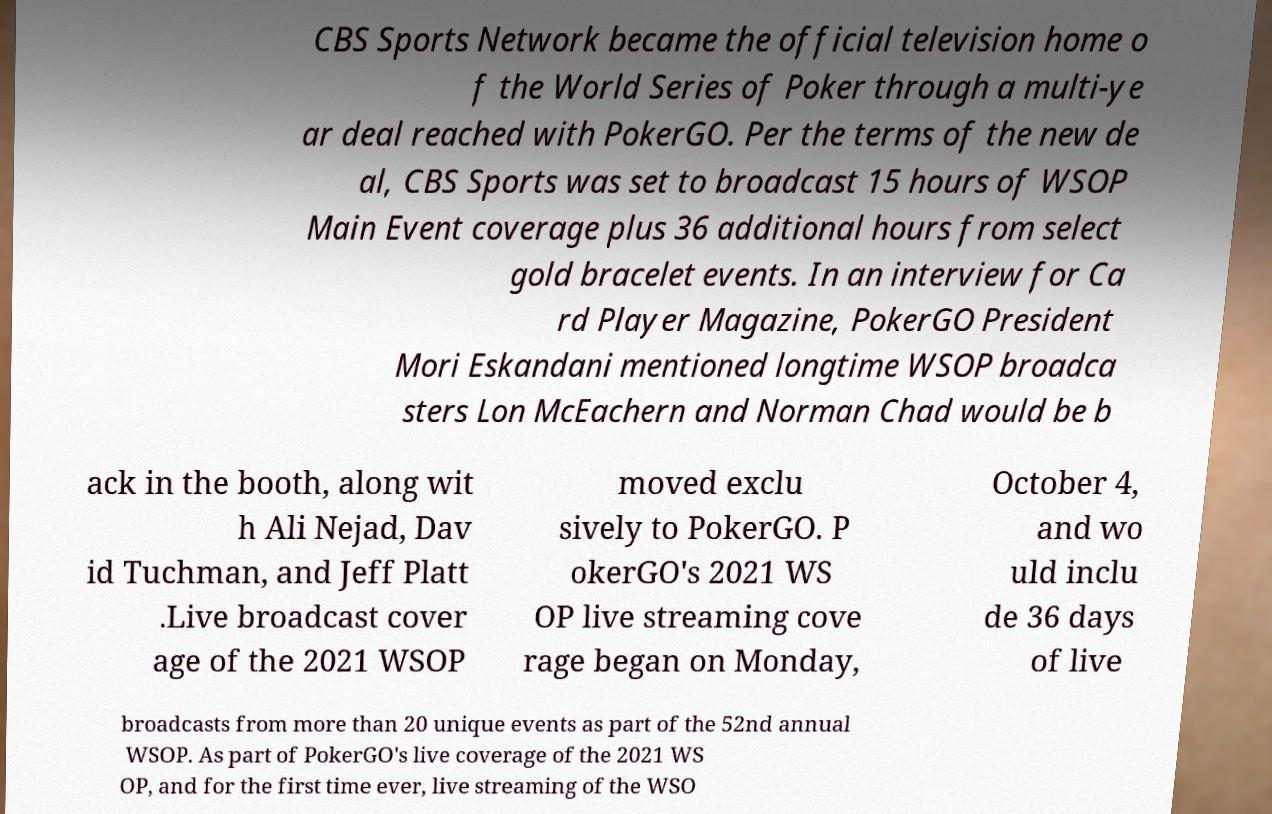What messages or text are displayed in this image? I need them in a readable, typed format. CBS Sports Network became the official television home o f the World Series of Poker through a multi-ye ar deal reached with PokerGO. Per the terms of the new de al, CBS Sports was set to broadcast 15 hours of WSOP Main Event coverage plus 36 additional hours from select gold bracelet events. In an interview for Ca rd Player Magazine, PokerGO President Mori Eskandani mentioned longtime WSOP broadca sters Lon McEachern and Norman Chad would be b ack in the booth, along wit h Ali Nejad, Dav id Tuchman, and Jeff Platt .Live broadcast cover age of the 2021 WSOP moved exclu sively to PokerGO. P okerGO's 2021 WS OP live streaming cove rage began on Monday, October 4, and wo uld inclu de 36 days of live broadcasts from more than 20 unique events as part of the 52nd annual WSOP. As part of PokerGO's live coverage of the 2021 WS OP, and for the first time ever, live streaming of the WSO 